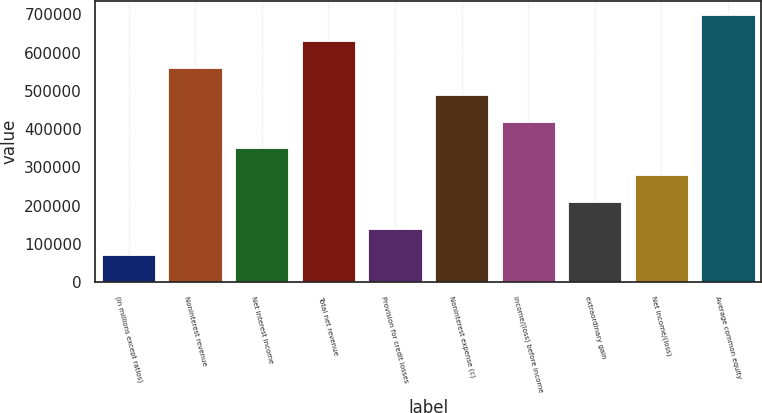Convert chart. <chart><loc_0><loc_0><loc_500><loc_500><bar_chart><fcel>(in millions except ratios)<fcel>Noninterest revenue<fcel>Net interest income<fcel>Total net revenue<fcel>Provision for credit losses<fcel>Noninterest expense (c)<fcel>Income/(loss) before income<fcel>extraordinary gain<fcel>Net income/(loss)<fcel>Average common equity<nl><fcel>69953.4<fcel>559242<fcel>349547<fcel>629141<fcel>139852<fcel>489344<fcel>419445<fcel>209750<fcel>279649<fcel>699039<nl></chart> 